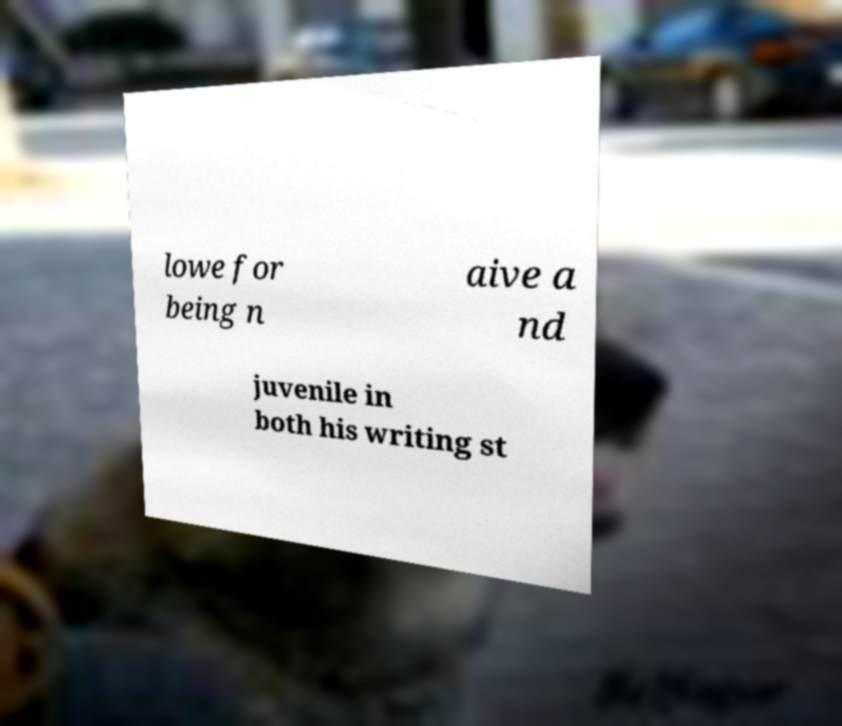I need the written content from this picture converted into text. Can you do that? lowe for being n aive a nd juvenile in both his writing st 